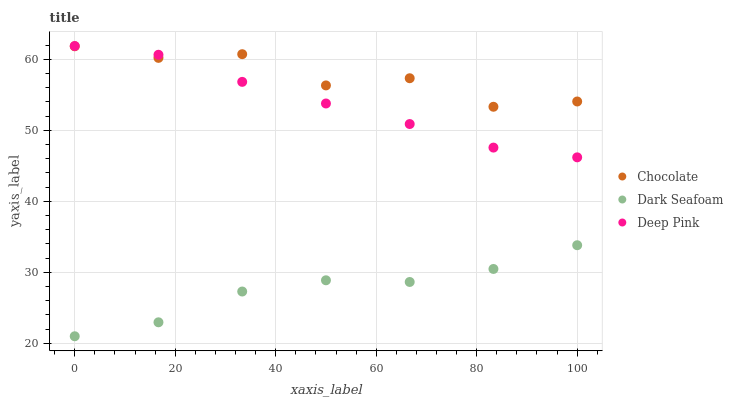Does Dark Seafoam have the minimum area under the curve?
Answer yes or no. Yes. Does Chocolate have the maximum area under the curve?
Answer yes or no. Yes. Does Deep Pink have the minimum area under the curve?
Answer yes or no. No. Does Deep Pink have the maximum area under the curve?
Answer yes or no. No. Is Deep Pink the smoothest?
Answer yes or no. Yes. Is Chocolate the roughest?
Answer yes or no. Yes. Is Chocolate the smoothest?
Answer yes or no. No. Is Deep Pink the roughest?
Answer yes or no. No. Does Dark Seafoam have the lowest value?
Answer yes or no. Yes. Does Deep Pink have the lowest value?
Answer yes or no. No. Does Deep Pink have the highest value?
Answer yes or no. Yes. Does Chocolate have the highest value?
Answer yes or no. No. Is Dark Seafoam less than Deep Pink?
Answer yes or no. Yes. Is Deep Pink greater than Dark Seafoam?
Answer yes or no. Yes. Does Deep Pink intersect Chocolate?
Answer yes or no. Yes. Is Deep Pink less than Chocolate?
Answer yes or no. No. Is Deep Pink greater than Chocolate?
Answer yes or no. No. Does Dark Seafoam intersect Deep Pink?
Answer yes or no. No. 